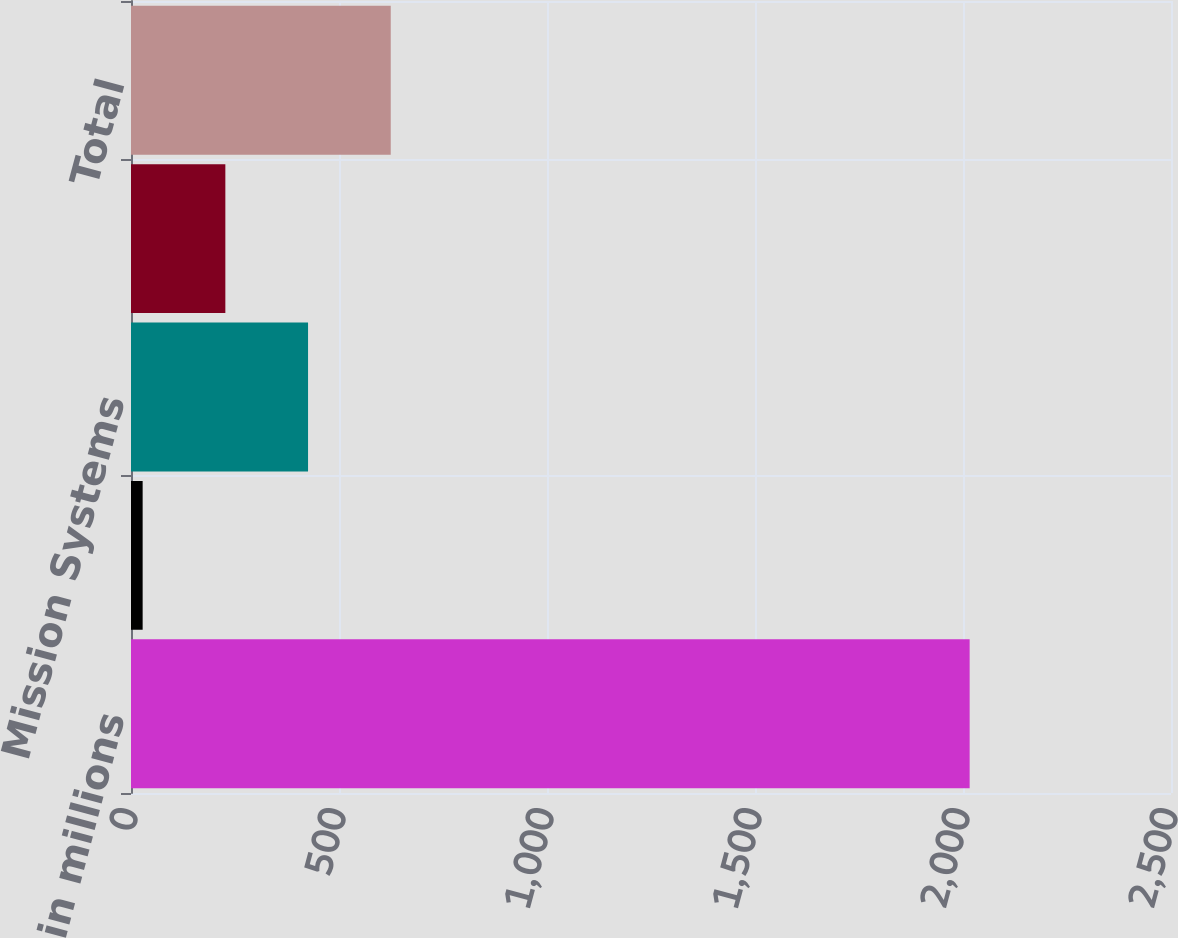Convert chart to OTSL. <chart><loc_0><loc_0><loc_500><loc_500><bar_chart><fcel>in millions<fcel>Aerospace Systems<fcel>Mission Systems<fcel>Technology Services<fcel>Total<nl><fcel>2016<fcel>28<fcel>425.6<fcel>226.8<fcel>624.4<nl></chart> 